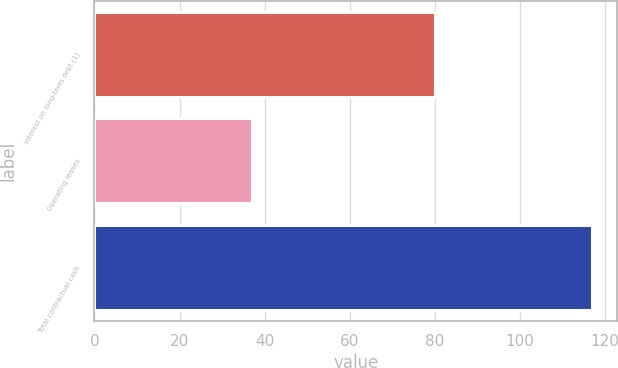Convert chart. <chart><loc_0><loc_0><loc_500><loc_500><bar_chart><fcel>Interest on long-term debt (1)<fcel>Operating leases<fcel>Total contractual cash<nl><fcel>80<fcel>37<fcel>117<nl></chart> 